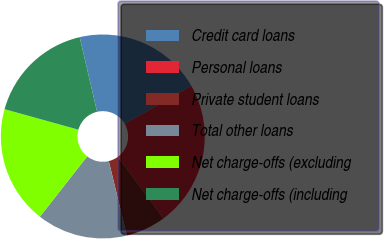<chart> <loc_0><loc_0><loc_500><loc_500><pie_chart><fcel>Credit card loans<fcel>Personal loans<fcel>Private student loans<fcel>Total other loans<fcel>Net charge-offs (excluding<fcel>Net charge-offs (including<nl><fcel>20.39%<fcel>23.12%<fcel>6.35%<fcel>14.37%<fcel>18.72%<fcel>17.05%<nl></chart> 